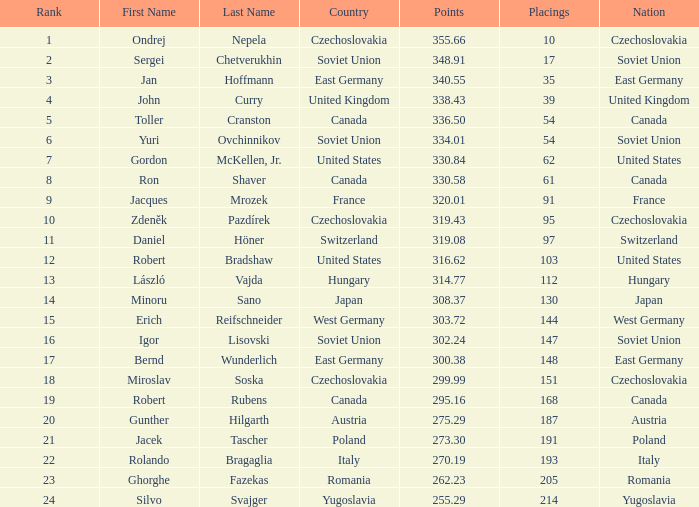Which Rank has a Name of john curry, and Points larger than 338.43? None. 